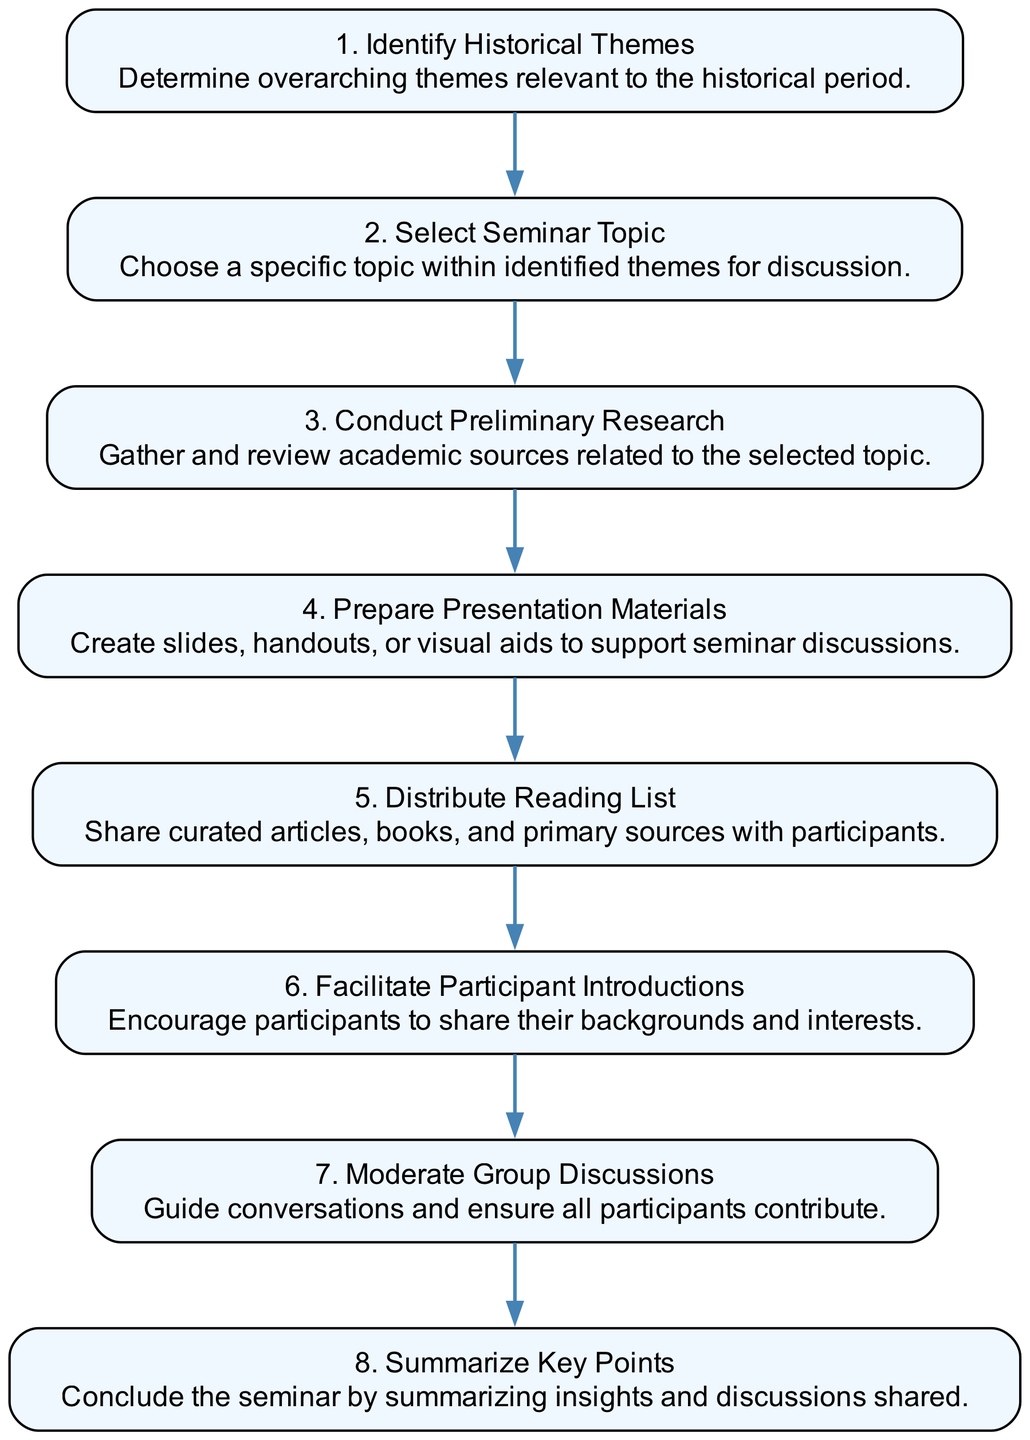What is the first step in the seminar methodology? The first step in the sequence diagram is "Identify Historical Themes." This is indicated as the starting node in the flow of the diagram.
Answer: Identify Historical Themes How many steps are there in total? By counting each step presented in the diagram from the first to the last, we find there are eight distinct steps.
Answer: 8 What step comes immediately after "Select Seminar Topic"? After "Select Seminar Topic," the next step in the sequence is "Conduct Preliminary Research." This relationship is indicated by a directed edge pointing from one to the other in the diagram.
Answer: Conduct Preliminary Research Which step involves sharing readings? The step labeled "Distribute Reading List" involves sharing curated articles, books, and primary sources with participants, as specifically described in the diagram.
Answer: Distribute Reading List What is the last step of the seminar methodology? The last step in the diagram is "Summarize Key Points," which concludes the seminar by summarizing insights and discussions shared.
Answer: Summarize Key Points Which step directly leads to participant engagement? "Facilitate Participant Introductions" is the step that directly leads to participant engagement by encouraging them to share their backgrounds and interests. This is essential for fostering a collaborative environment.
Answer: Facilitate Participant Introductions How does research preparation relate to topic selection? "Conduct Preliminary Research" follows directly after "Select Seminar Topic," indicating that research preparation is dependent on having chosen a specific topic for discussion within the identified historical themes. This shows a logical sequence where topic selection informs the research process.
Answer: Research preparation is dependent on topic selection What elements form the conclusion of the seminar? The conclusion is formed by the "Summarize Key Points," which acts as a wrap-up reflecting on the insights shared, culminating the entire seminar process. This summarization encapsulates all the discussions held.
Answer: Summarize Key Points 